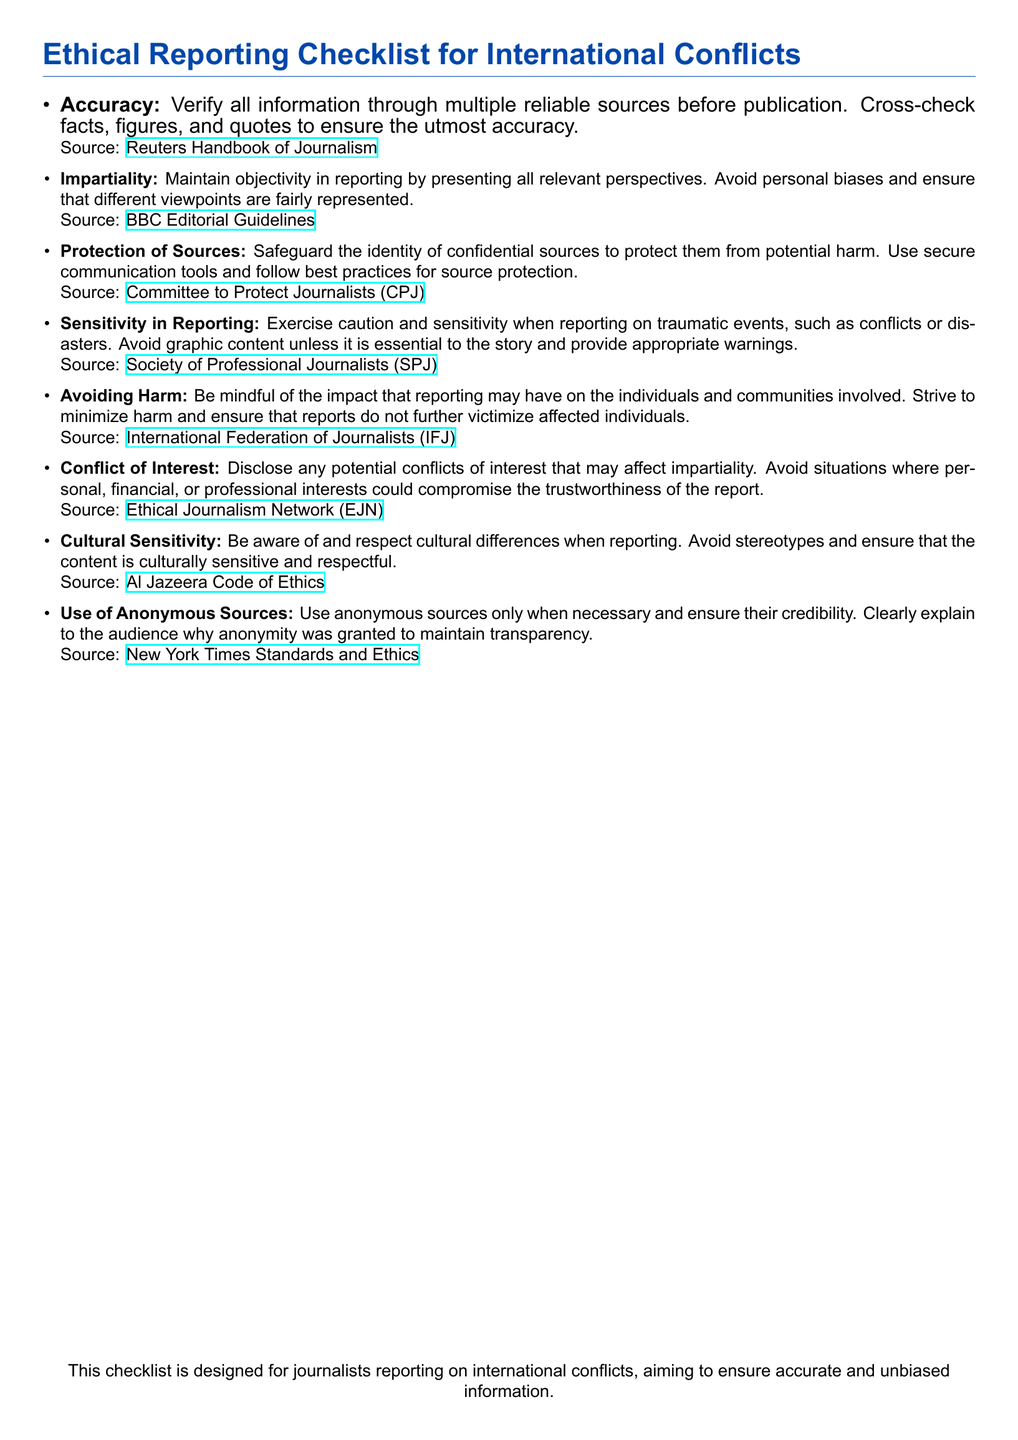What is the main purpose of the checklist? The main purpose of the checklist is designed for journalists reporting on international conflicts, aiming to ensure accurate and unbiased information.
Answer: accurate and unbiased information How many considerations are listed in the checklist? The total number of considerations provided in the checklist is counted from the list, which is eight.
Answer: eight Which source emphasizes the importance of protecting sources? The consideration regarding the protection of sources cites the Committee to Protect Journalists (CPJ) as the source emphasizing this importance.
Answer: Committee to Protect Journalists (CPJ) What is the guideline for reporting on traumatic events? The guideline advises to exercise caution and sensitivity when reporting on traumatic events, such as conflicts or disasters.
Answer: caution and sensitivity What should be disclosed to maintain impartiality? The checklist states that any potential conflicts of interest that may affect impartiality should be disclosed.
Answer: potential conflicts of interest Which document emphasizes avoiding stereotypes in reporting? The Al Jazeera Code of Ethics is the document that emphasizes avoiding stereotypes and ensuring content is culturally sensitive.
Answer: Al Jazeera Code of Ethics What does the checklist suggest regarding anonymous sources? It suggests to use anonymous sources only when necessary and ensure their credibility.
Answer: use only when necessary Which organization provides guidelines on avoiding harm in reporting? The organization that provides guidelines on avoiding harm is the International Federation of Journalists (IFJ).
Answer: International Federation of Journalists (IFJ) 